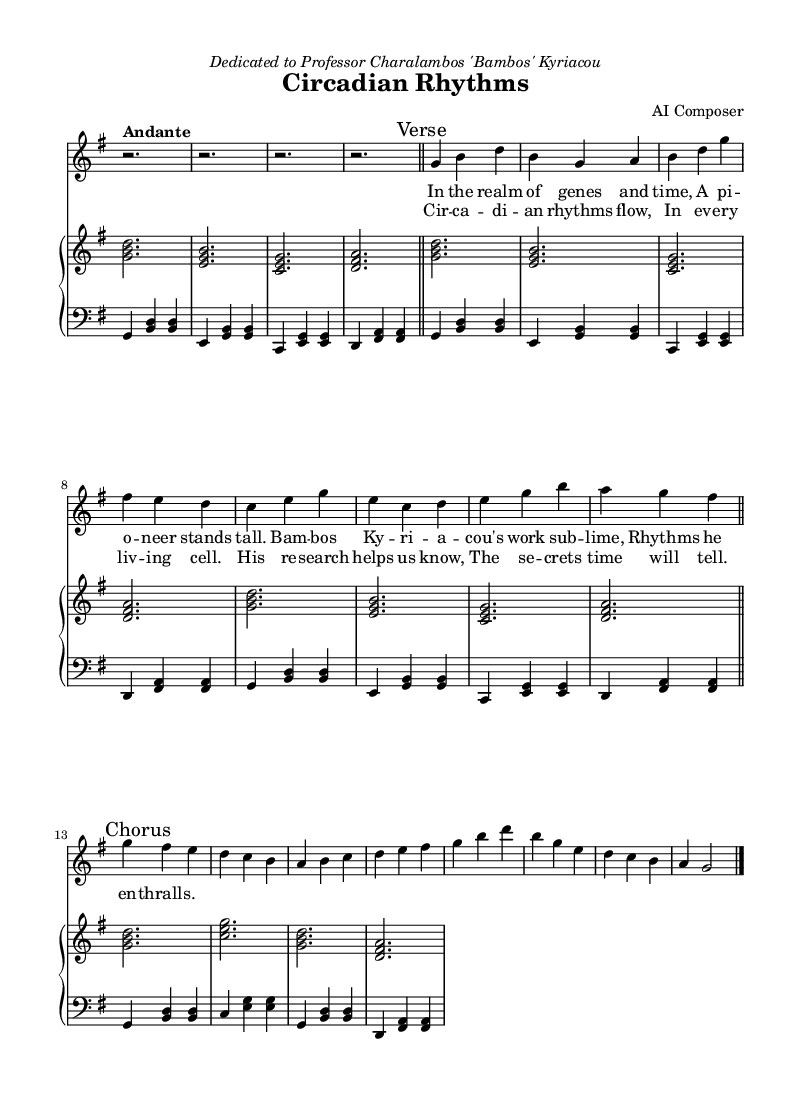What is the key signature of this music? The key signature is indicated by the sharp signs at the beginning of the staff. In this case, it is G major, which has one sharp (F#).
Answer: G major What is the time signature of this music? The time signature is displayed at the beginning of the score, showing the number of beats in a measure. Here it is 3/4, which means there are three beats per measure and the quarter note gets the beat.
Answer: 3/4 What is the specified tempo for the piece? The tempo marking appears above the staff, written as "Andante," indicating a moderate pace. This provides insight into how the piece is meant to be performed.
Answer: Andante How many measures does the score contain? To find the number of measures, one can count the vertical lines (bar lines) separating sections. There are twelve measures total.
Answer: 12 What is the form of the piece? The score indicates segments with "Verse" and "Chorus" marks, indicating a structure typical of lyrical art songs. This suggests a form that alternates between verses and refrains.
Answer: Verse and Chorus What kind of lyrics does this piece celebrate? The lyrics celebrate the work of a scientist, specifically focusing on circadian rhythms and their significance in genetics research, alluding to Professor Kyriacou’s contributions.
Answer: Pioneering scientist What is the vocal range indicated for the soprano part? The soprano part starts relatively high and includes notes that would typically lie within the soprano range, up to a g'. The range suggests a focus on lyrical expressiveness.
Answer: Soprano 